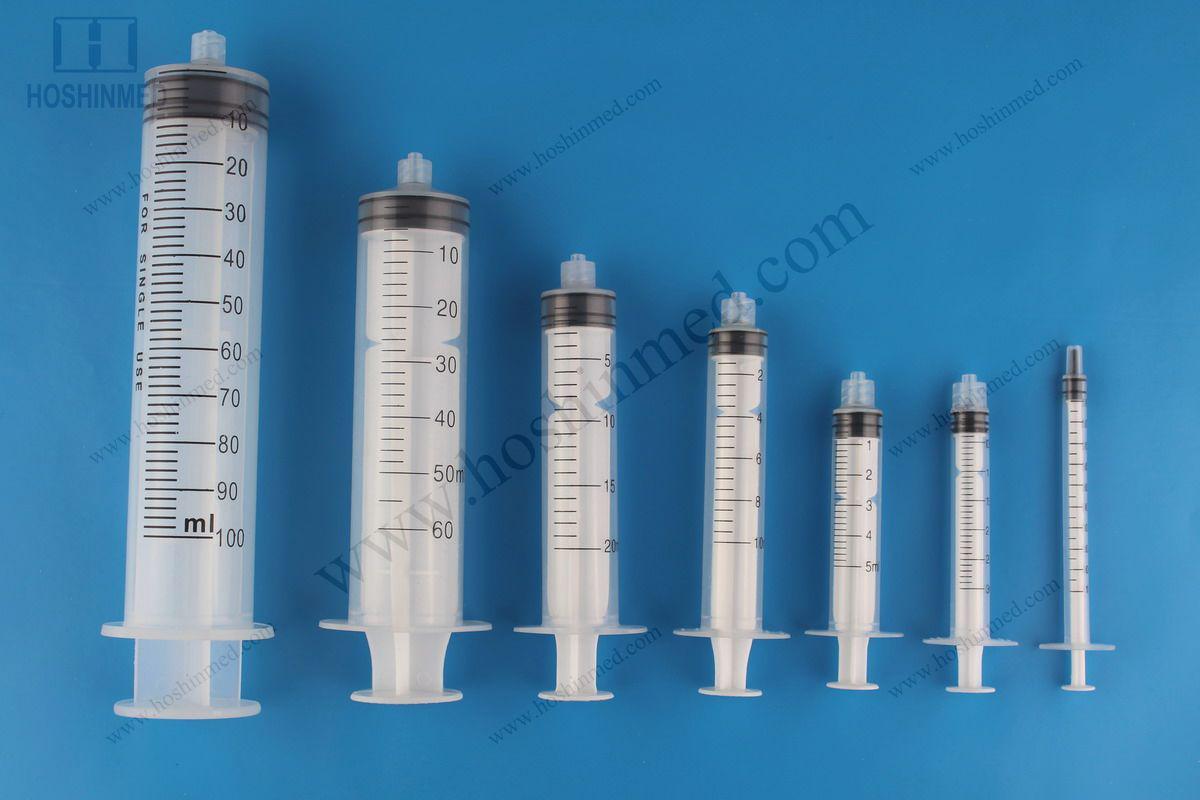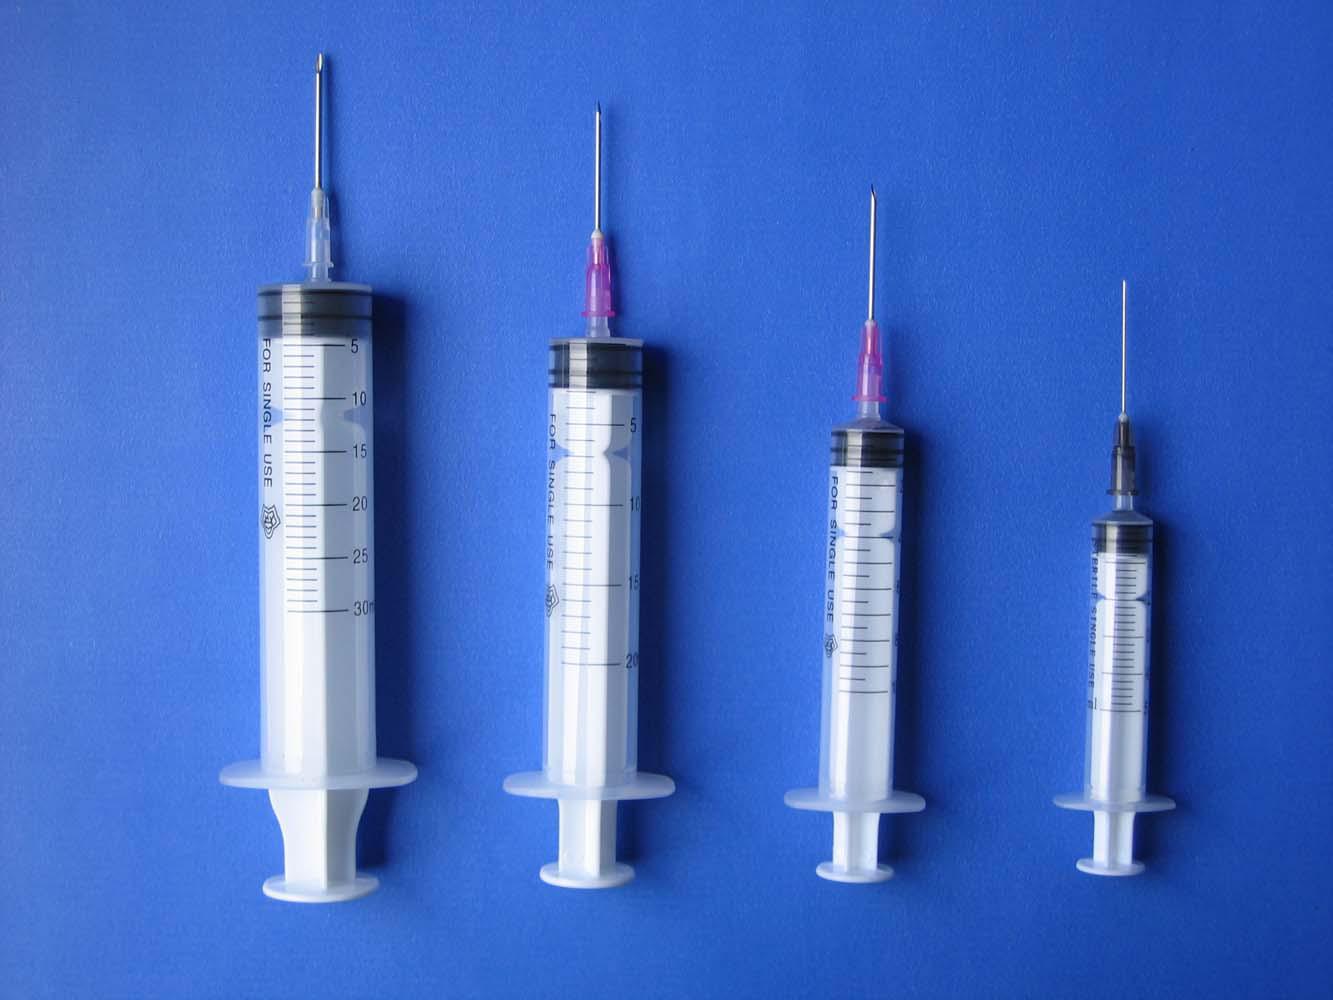The first image is the image on the left, the second image is the image on the right. Given the left and right images, does the statement "In one of the images, there are no needles attached to the syringes." hold true? Answer yes or no. Yes. The first image is the image on the left, the second image is the image on the right. Considering the images on both sides, is "Each image contains more than four syringes." valid? Answer yes or no. No. 